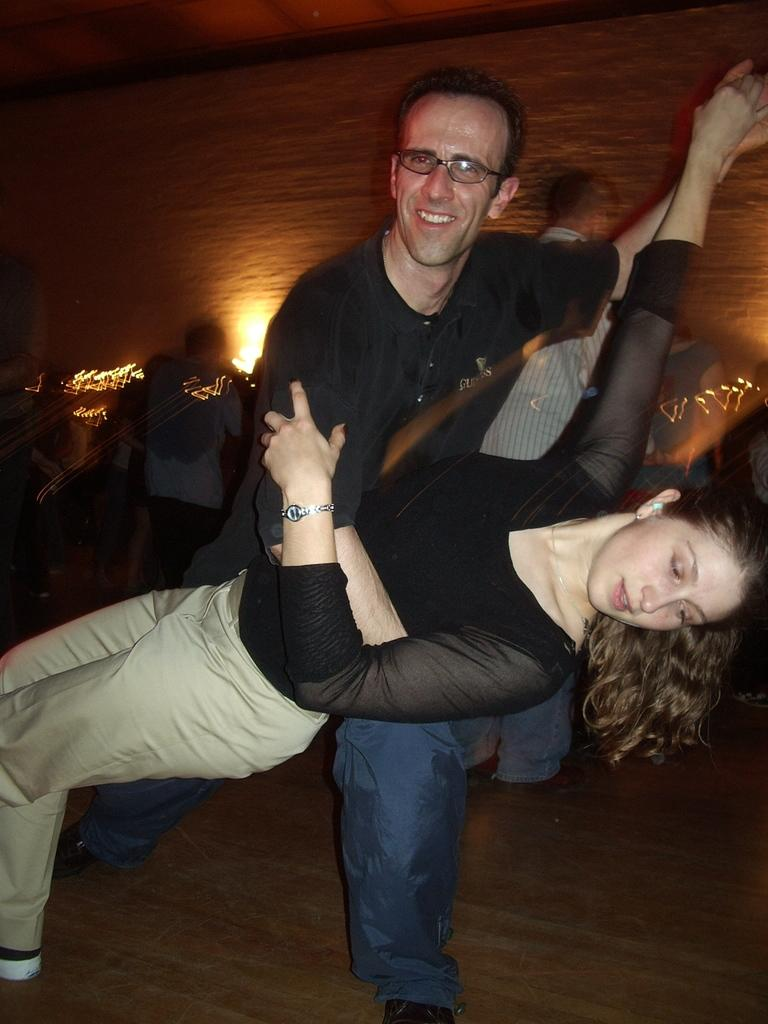How many people are in the image? There is a group of people in the image, but the exact number is not specified. What is the position of the people in the image? The people are standing on the floor in the image. What can be seen on the left side of the image? There are lights on the left side of the image. What is visible at the top of the image? The roof is visible at the top of the image. How many legs can be seen on the tent in the image? There is no tent present in the image, so it is not possible to determine the number of legs on a tent. 